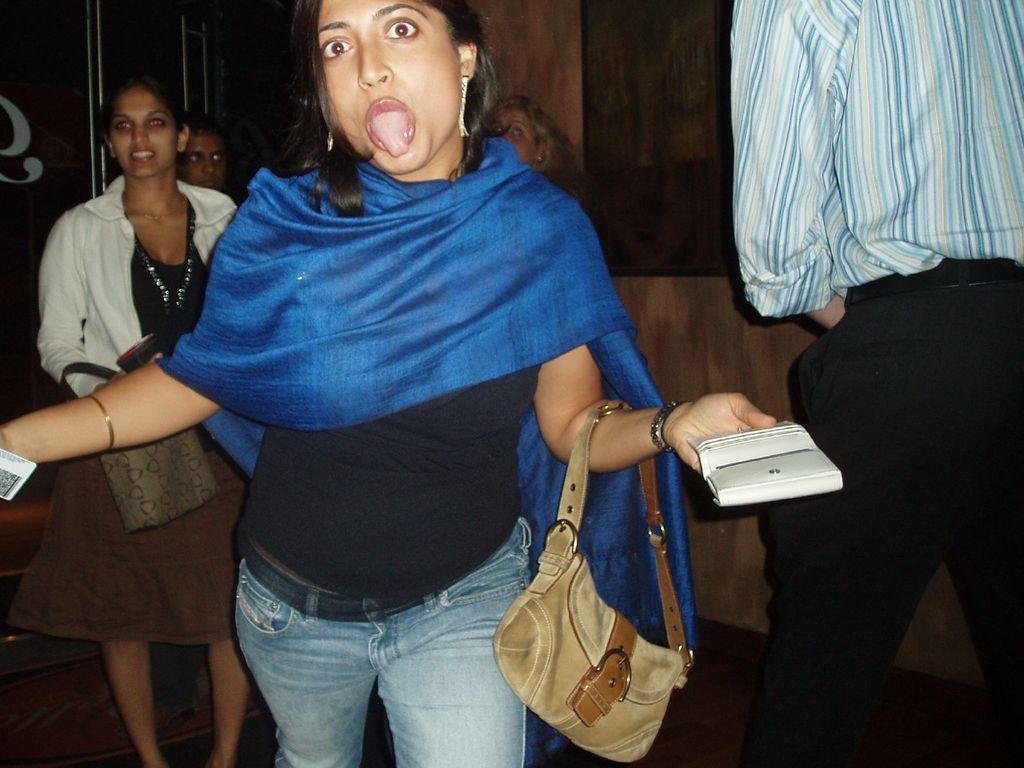Describe this image in one or two sentences. These persons are standing. This person holding bag,wallet. This person holding bag. On the background we can see wall. This is floor. 